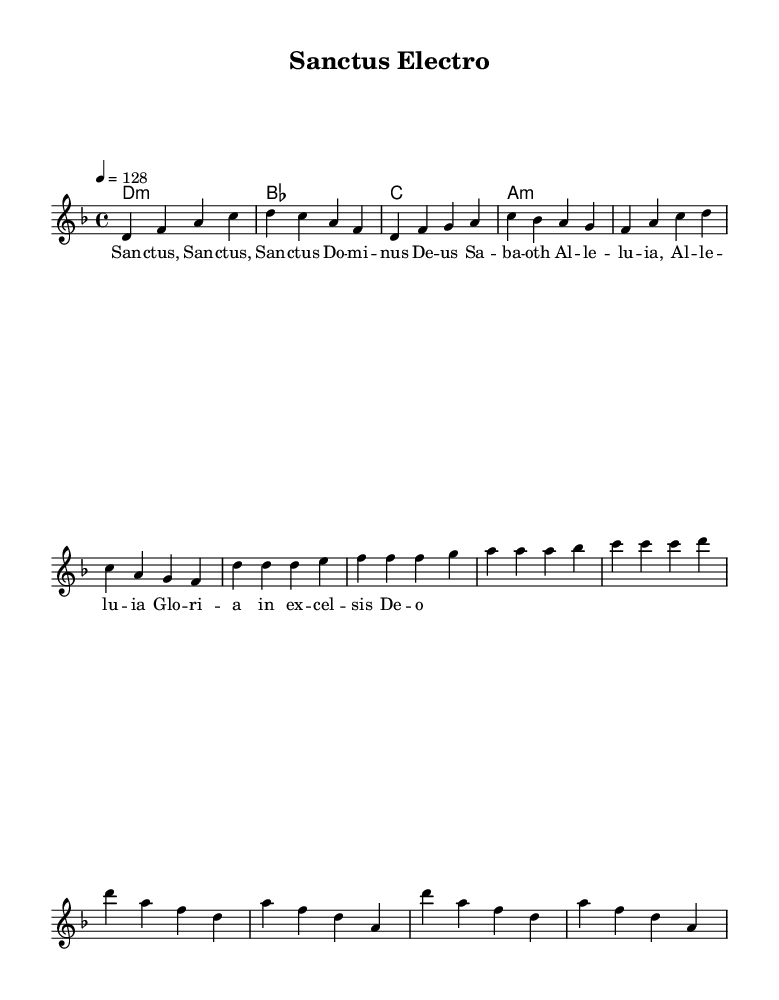What is the key signature of this music? The key signature is indicated by the positions of the sharps and flats at the beginning of the staff. In this case, there are no sharps or flats shown, which means the key signature is D minor, as indicated in the global section.
Answer: D minor What is the time signature of this music? The time signature is found in the initial part of the score layout. It is written as a fraction consisting of the numbers 4 and 4, indicating that there are four beats per measure and a quarter note receives one beat.
Answer: 4/4 What is the tempo marking of this music? The tempo is indicated by the numeric tempo marking in the global section, which specifies the beats per minute. Here it is written as "4 = 128", meaning the quarter note is set to 128 beats per minute.
Answer: 128 How many measures are in the melody section? To determine the number of measures, we can count the groups separated by vertical lines in the melody part. Each group represents a measure, and there are a total of 8 measures in the melody section.
Answer: 8 What is the first note of the melody? The first note is found at the beginning of the melody section on the staff. It is the note 'd' in the first measure, as indicated by its placement on the staff.
Answer: d What type of chords are used in the harmonies section? The chords are identified by their notations in the chord mode section, which show root notes along with their qualities. The first chord is a D minor chord, followed by a B flat major, C major, and an A minor.
Answer: Minor and major What is the lyrical theme of the piece? The lyrics are structured in a repetitive chant-like manner, as indicated in the lyrics section just below the melody. They focus on praises to God, specifically referring to "Sanctus" which means "Holy".
Answer: Sanctus 